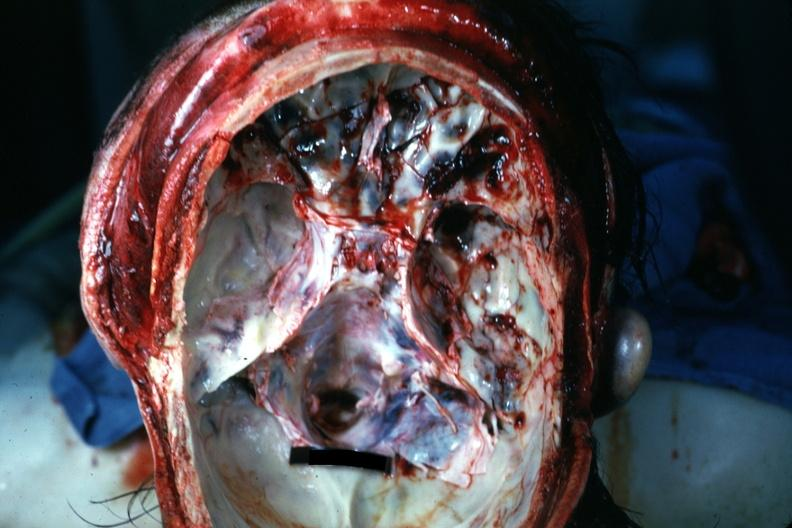s intrauterine contraceptive device present?
Answer the question using a single word or phrase. No 